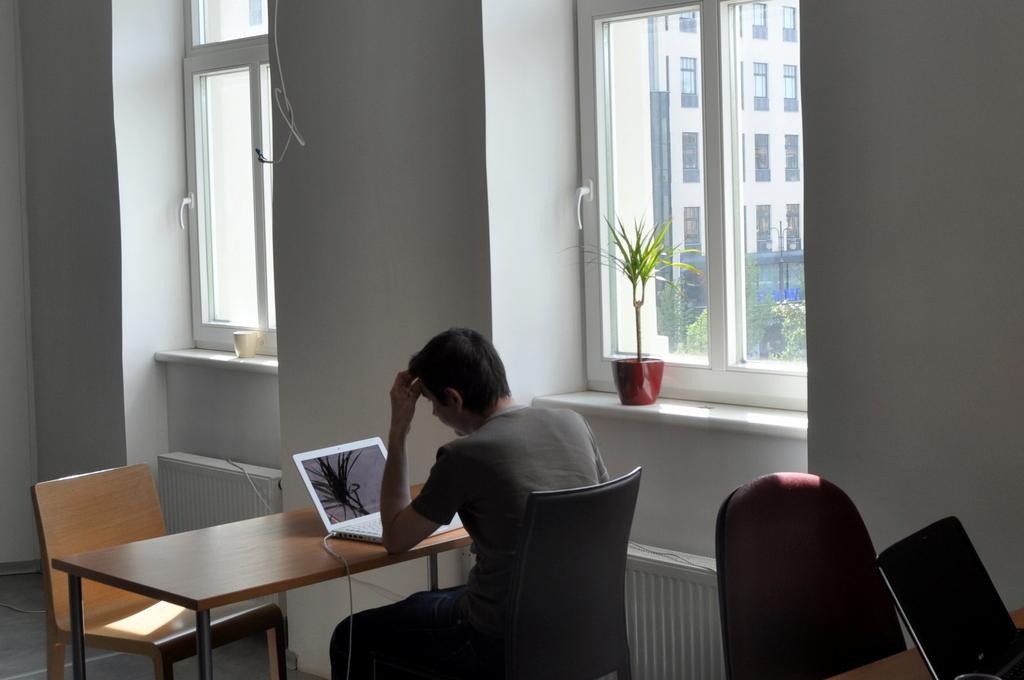What is the man doing in the image? The man is sitting on a table. What object is the man using while sitting on the table? The man has a laptop on the table. What type of structure can be seen in the image? There is a glass window in the image. What small object is present in the image? There is a small flower pot in the image. What type of sugar does the man's brother use in his coffee in the image? There is no mention of coffee or a brother in the image, so it is impossible to determine the type of sugar used. 